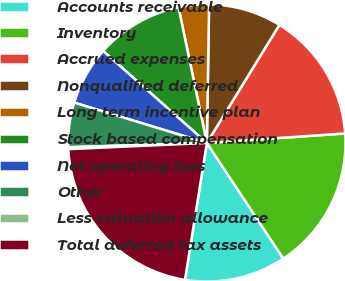Convert chart. <chart><loc_0><loc_0><loc_500><loc_500><pie_chart><fcel>Accounts receivable<fcel>Inventory<fcel>Accrued expenses<fcel>Nonqualified deferred<fcel>Long term incentive plan<fcel>Stock based compensation<fcel>Net operating loss<fcel>Other<fcel>Less valuation allowance<fcel>Total deferred tax assets<nl><fcel>11.82%<fcel>16.8%<fcel>15.14%<fcel>8.51%<fcel>3.54%<fcel>10.17%<fcel>6.85%<fcel>5.19%<fcel>0.22%<fcel>21.77%<nl></chart> 